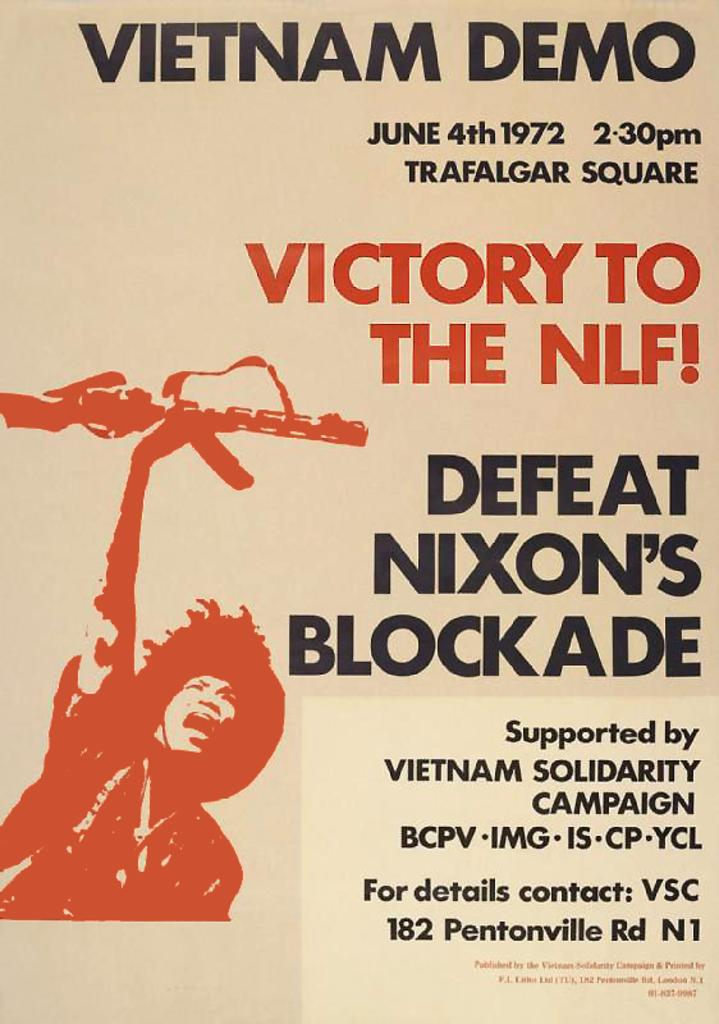<image>
Offer a succinct explanation of the picture presented. The poster ad is for a Vietnam Demo 